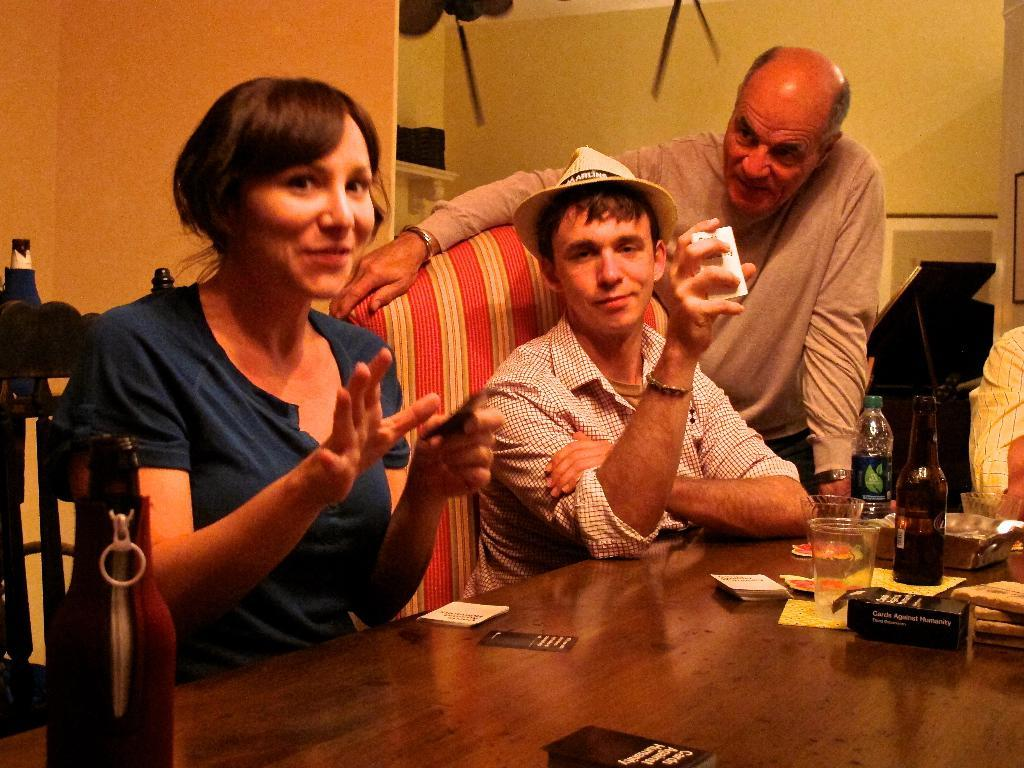How many people are in the room in the image? There are four people in the room, two men and two women. What are the people in the room doing? The men and women are sitting on chairs in the room. What is in front of the people sitting in the room? There is a table in front of them. What can be seen on the table? There are many items on the table. What type of bear can be seen interacting with the family in the image? There is no bear present in the image; it features four people sitting around a table with many items. How do the people in the image maintain their balance while sitting on the chairs? The people in the image are not shown performing any actions that would require balancing, and the chairs appear to be stable. 